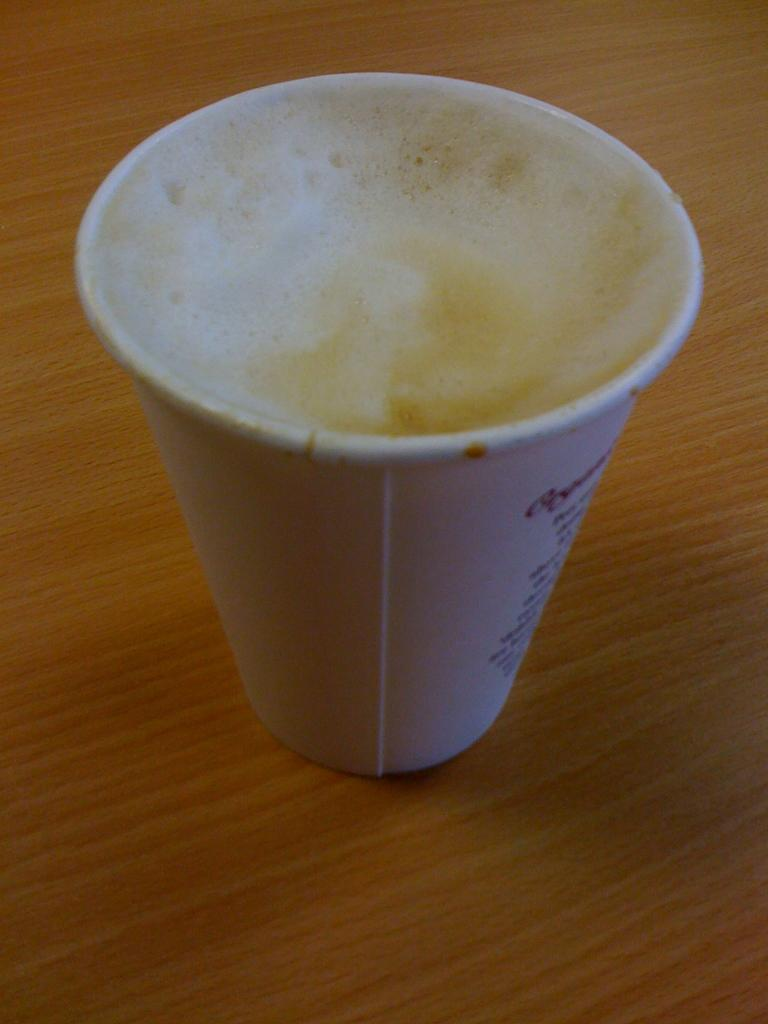What is present on the wooden surface in the image? There is a cup on the wooden surface. What is the cup holding? The cup is holding foam. What type of connection is being offered by the horn in the image? There is no horn present in the image, so no connection is being offered. 